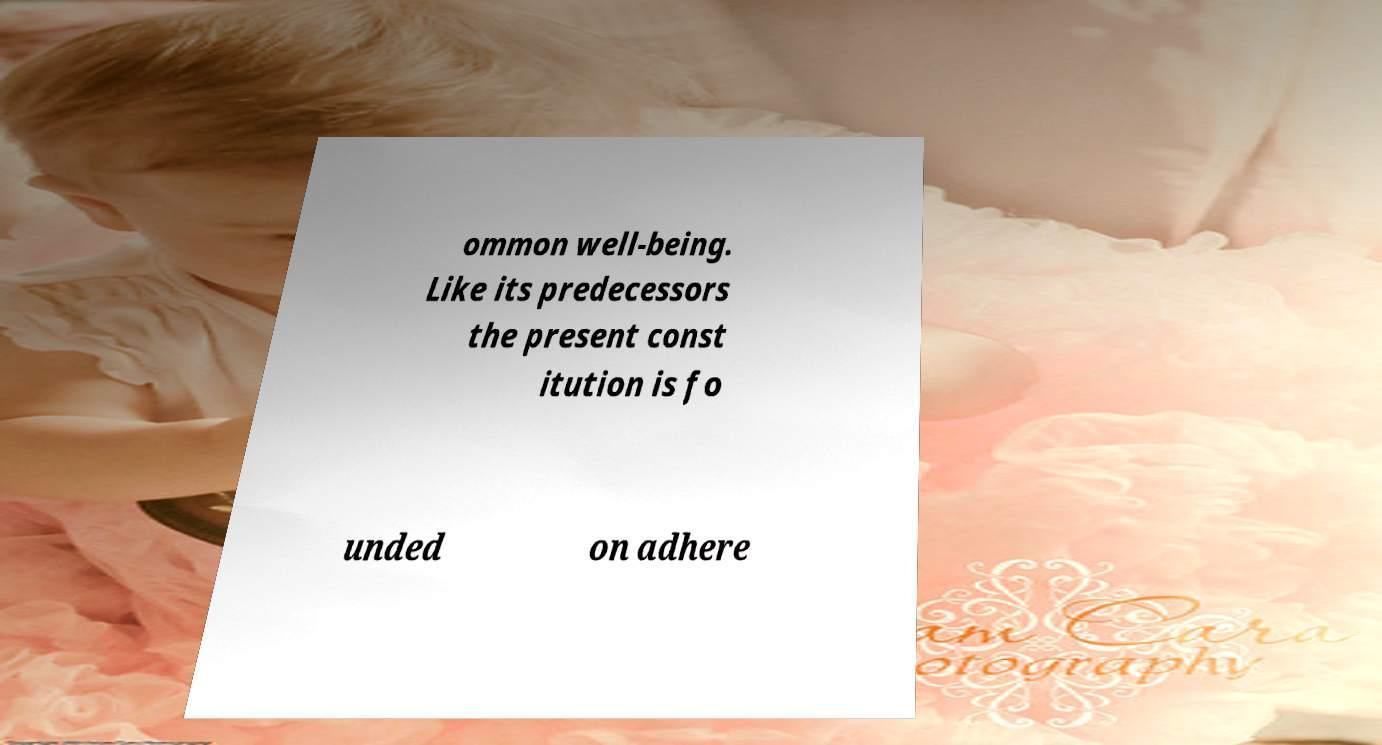What messages or text are displayed in this image? I need them in a readable, typed format. ommon well-being. Like its predecessors the present const itution is fo unded on adhere 